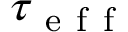Convert formula to latex. <formula><loc_0><loc_0><loc_500><loc_500>\tau _ { e f f }</formula> 